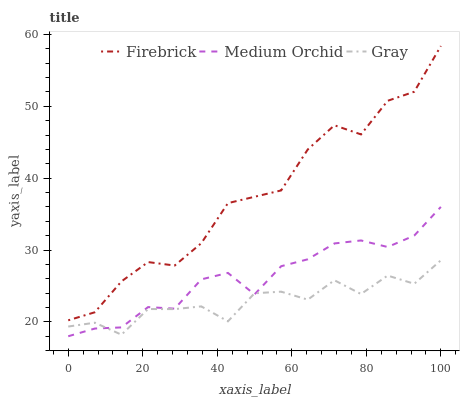Does Medium Orchid have the minimum area under the curve?
Answer yes or no. No. Does Medium Orchid have the maximum area under the curve?
Answer yes or no. No. Is Firebrick the smoothest?
Answer yes or no. No. Is Firebrick the roughest?
Answer yes or no. No. Does Firebrick have the lowest value?
Answer yes or no. No. Does Medium Orchid have the highest value?
Answer yes or no. No. Is Medium Orchid less than Firebrick?
Answer yes or no. Yes. Is Firebrick greater than Medium Orchid?
Answer yes or no. Yes. Does Medium Orchid intersect Firebrick?
Answer yes or no. No. 